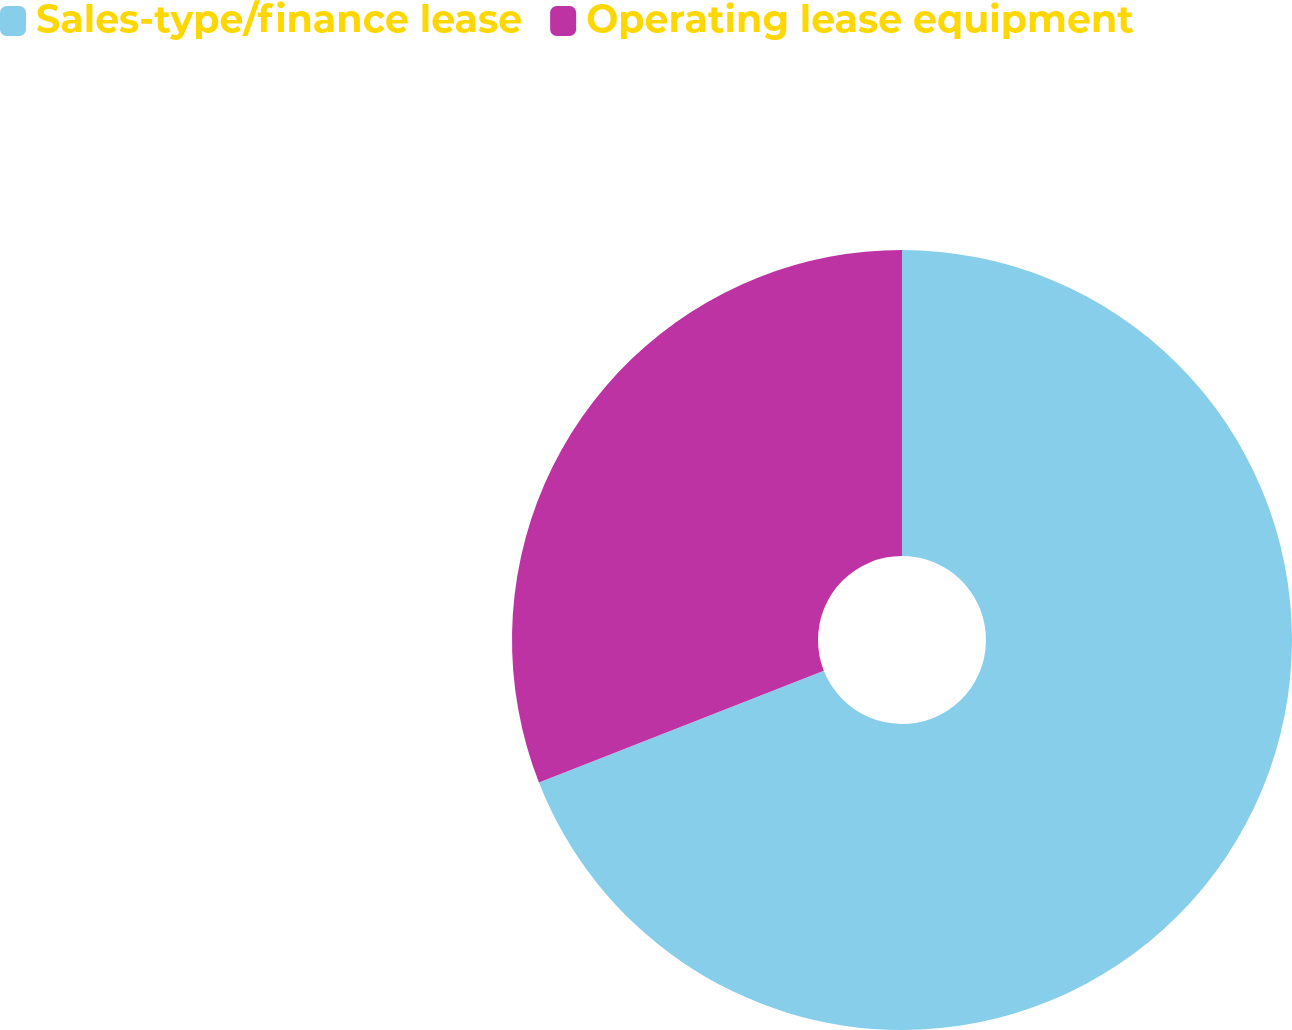Convert chart. <chart><loc_0><loc_0><loc_500><loc_500><pie_chart><fcel>Sales-type/finance lease<fcel>Operating lease equipment<nl><fcel>69.05%<fcel>30.95%<nl></chart> 